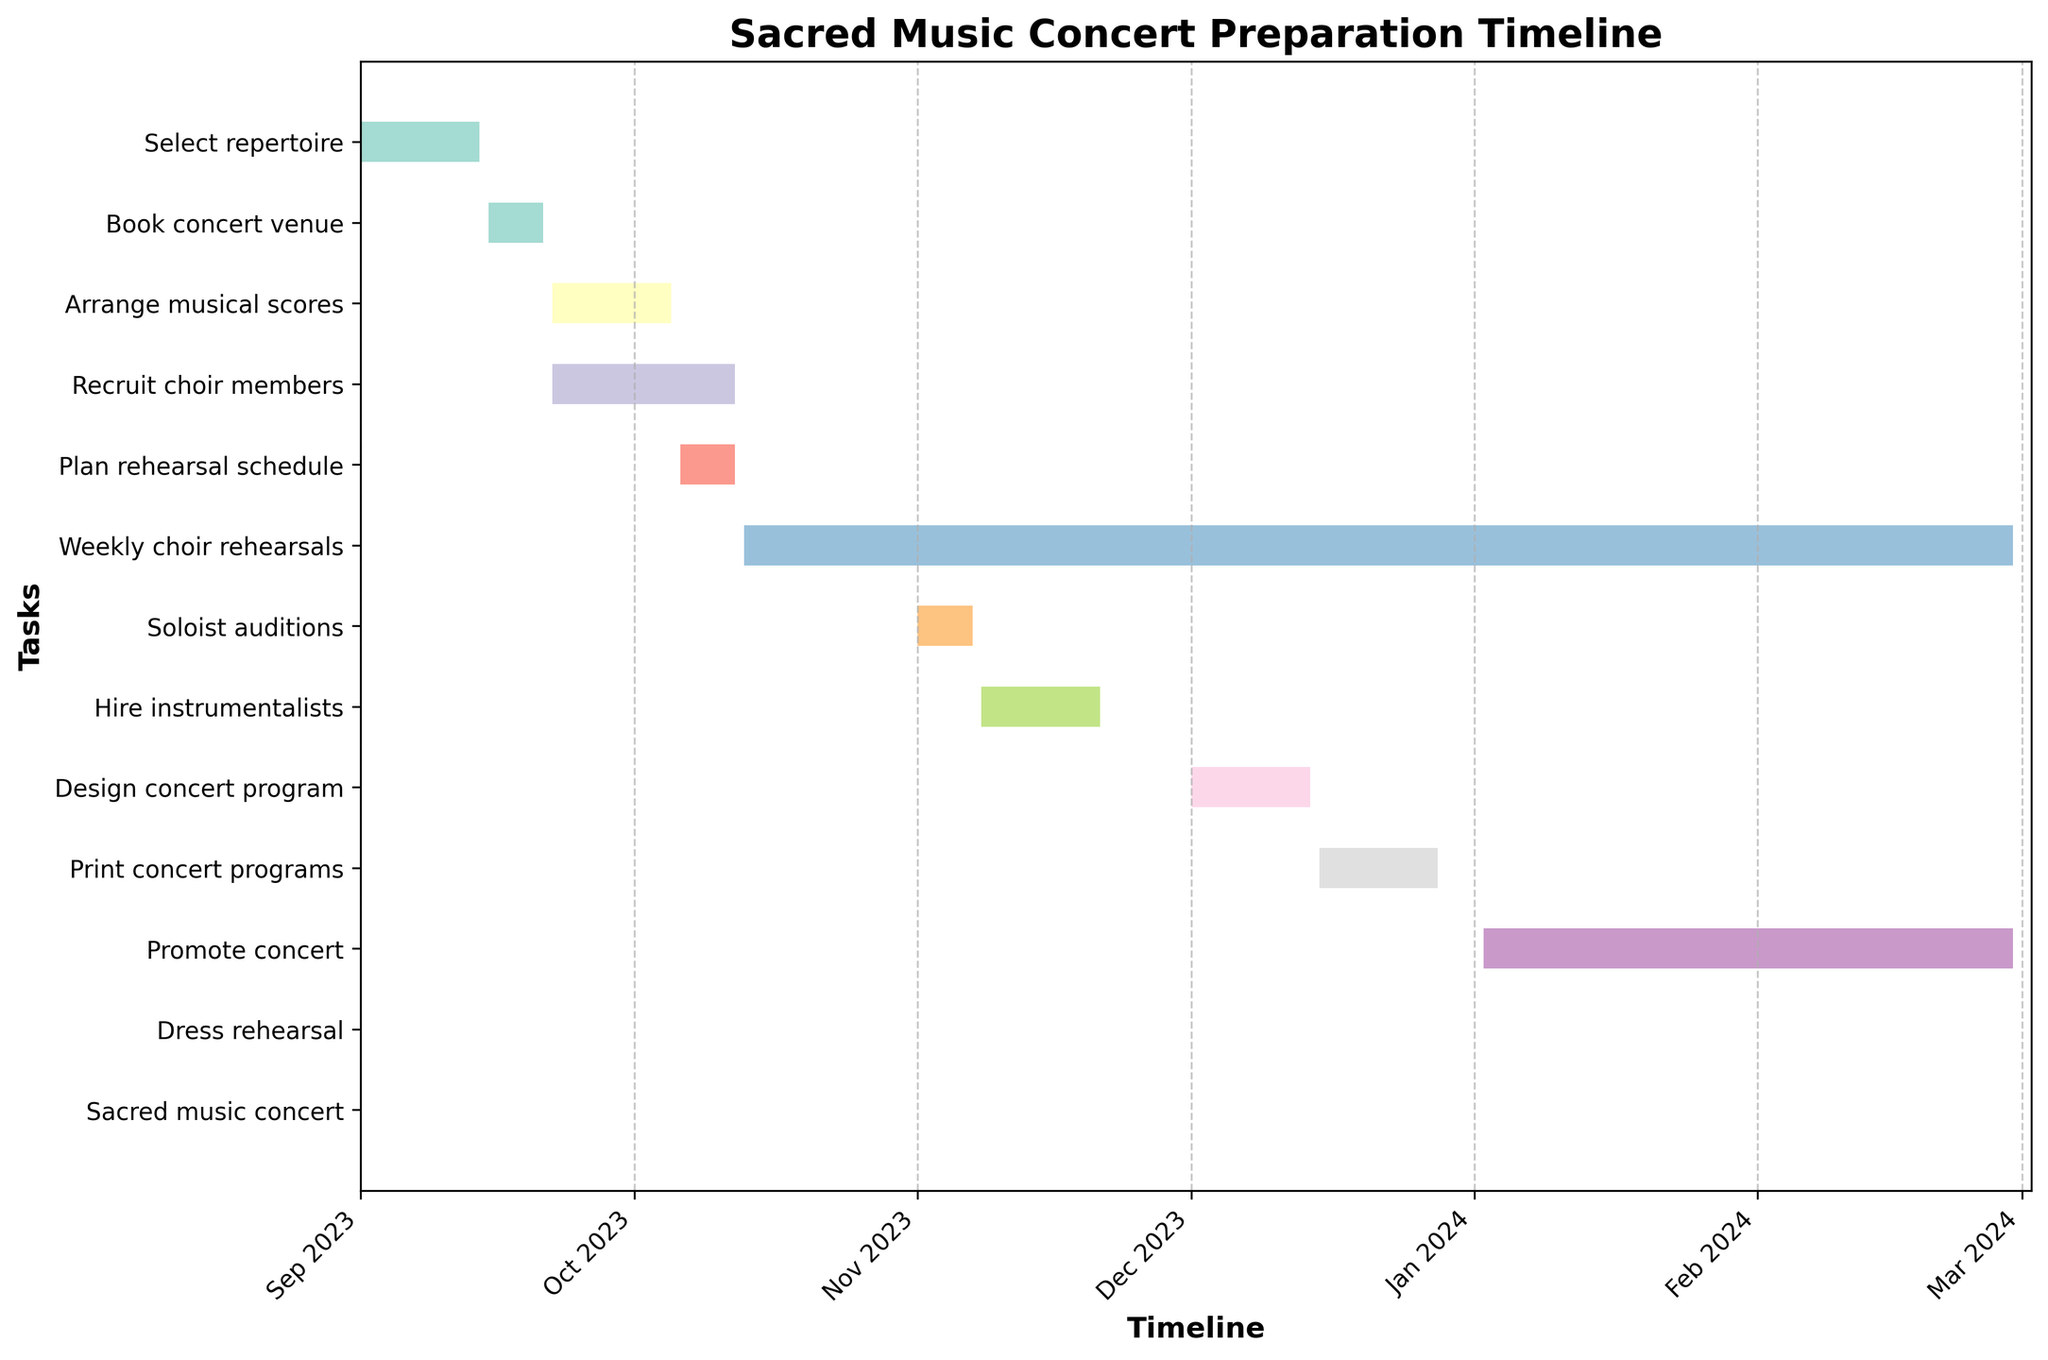How many tasks are listed in the Gantt chart? Count the number of horizontal bars or tasks listed along the y-axis.
Answer: 12 Which task is scheduled to start first? Identify the task whose bar starts at the earliest date on the x-axis.
Answer: Select repertoire What is the duration of the "Weekly choir rehearsals" task? Check the length of the bar representing "Weekly choir rehearsals" and calculate the number of days between its start and end dates.
Answer: 140 days How many tasks are ongoing in October 2023? Identify the bars that overlap with October 2023 on the x-axis.
Answer: 3 tasks (Arrange musical scores, Recruit choir members, Plan rehearsal schedule) Which task ends last? Find the task whose bar ends at the latest date on the x-axis.
Answer: Promote concert What is the overlap period between the tasks "Select repertoire" and "Book concert venue"? Look at the intervals for these tasks on the x-axis and find the intersection period. September 15, 2023 - September 21, 2023 is after September 14, 2023. No overlap between these tasks.
Answer: No overlap Are there any tasks that start and end on the same day? Verify if any bar has its start date equal to its end date.
Answer: Yes, Dress rehearsal and Sacred music concert Which months have the highest number of tasks starting? Compare the x-axis positions where the tasks begin, count for each month, and find the month with the highest count.
Answer: October 2023 What tasks are completed by the end of December 2023? Identify the bars that have their end date by the end of December 2023 on the x-axis.
Answer: Select repertoire, Book concert venue, Arrange musical scores, Recruit choir members, Plan rehearsal schedule, Soloist auditions, Hire instrumentalists, Design concert program, Print concert programs How long is the preparation period for the "Promote concert" task? Check the length of the bar representing "Promote concert" and calculate the number of days between its start and end dates.
Answer: 58 days 